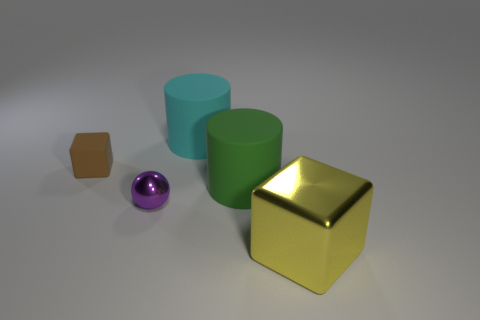Add 1 yellow objects. How many objects exist? 6 Subtract all cubes. How many objects are left? 3 Add 2 big blocks. How many big blocks are left? 3 Add 5 big yellow rubber objects. How many big yellow rubber objects exist? 5 Subtract 1 yellow blocks. How many objects are left? 4 Subtract all green cylinders. Subtract all large green cylinders. How many objects are left? 3 